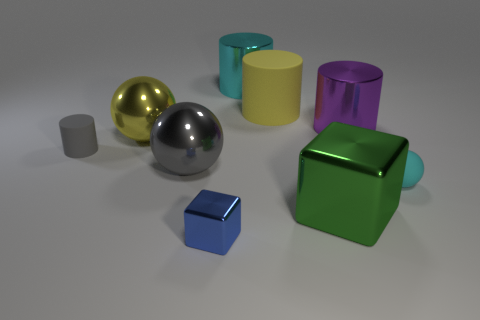What is the shape of the big thing that is in front of the small cyan matte object?
Give a very brief answer. Cube. Are there more large yellow rubber cylinders than yellow cubes?
Your response must be concise. Yes. Does the large metallic ball that is behind the tiny gray matte cylinder have the same color as the tiny metal object?
Offer a terse response. No. How many objects are either tiny objects that are on the left side of the small shiny cube or large shiny things left of the large purple shiny cylinder?
Your answer should be very brief. 5. How many objects are both left of the yellow cylinder and behind the large yellow ball?
Ensure brevity in your answer.  1. Is the green object made of the same material as the large yellow cylinder?
Your answer should be very brief. No. The cyan thing right of the metal cylinder that is left of the rubber cylinder on the right side of the cyan cylinder is what shape?
Offer a very short reply. Sphere. The thing that is both in front of the gray metal thing and on the left side of the green metallic thing is made of what material?
Provide a succinct answer. Metal. There is a matte object right of the big metallic object in front of the tiny rubber object that is to the right of the big green metal object; what color is it?
Offer a terse response. Cyan. How many brown things are either small cylinders or rubber cylinders?
Offer a terse response. 0. 